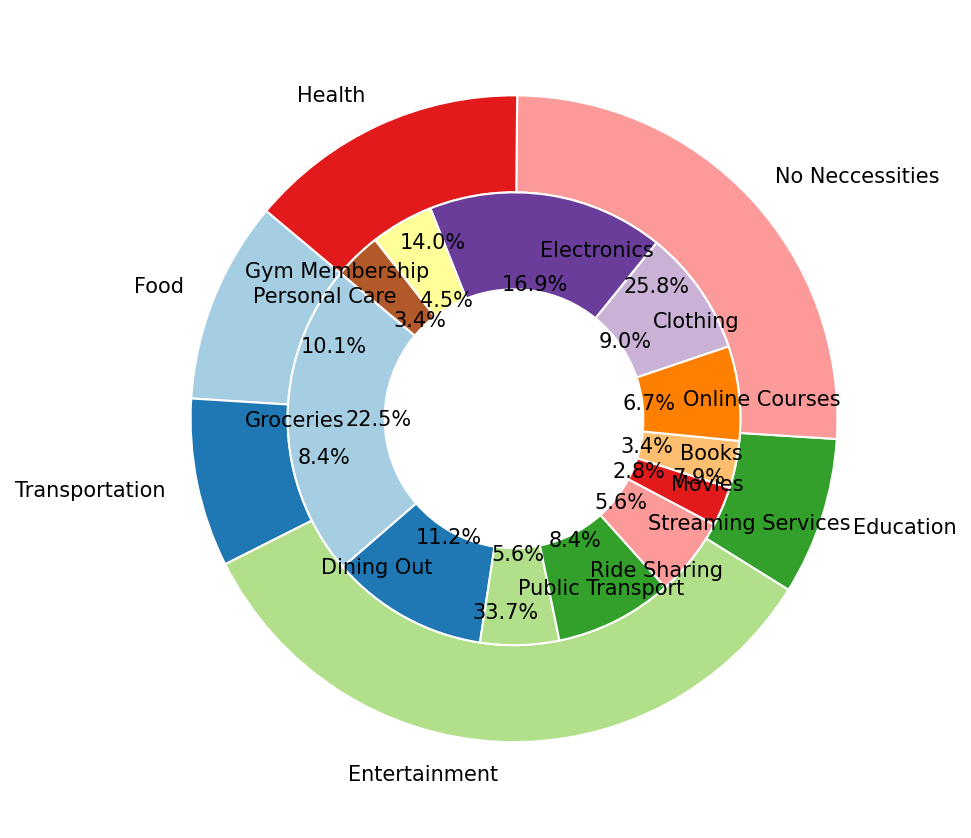What category has the highest monthly expense? By looking at the outer pie chart, we can identify the category with the largest section. Food, with its subcategories Groceries and Dining Out, has the highest monthly expense.
Answer: Food What is the total monthly expense for the Entertainment category? Add the monthly expenses for the subcategories Streaming Services ($50) and Movies ($25). This gives $50 + $25 = $75.
Answer: $75 Which subcategory within the Transportation category has a higher monthly expense? By comparing the sections within Transportation, Ride Sharing has a higher expense ($75) compared to Public Transport ($50).
Answer: Ride Sharing What is the color of the section representing the Education category's total monthly expenditure? The outer pie chart segment marked as Education, which includes Books and Online Courses, is colored light blue-ish in the chart.
Answer: Light Blue How many categories have only one subcategory and what are they? From the pie chart, identify the categories with single sections in the inner pie chart. These are Health and Non-Necessities, as Gym Membership and Electronics are their sole subcategories.
Answer: Two, Health and Non-Necessities Which subcategory has the lowest frequency of purchases? By looking at the inner pie chart, the subcategory with the smallest section in frequency (1 purchase) and monthly expense is Electronics within Non-Necessities.
Answer: Electronics Which category has the smallest proportion of the total monthly expense, and what is its monthly expense? The smallest outer pie chart segment of a category represents Health, made up of Gym Membership ($40) and Personal Care ($30), summing to $70.
Answer: Health, $70 How does the percentage of monthly expense on Groceries compare to Dining Out? Visually, Groceries takes a larger slice in the inner pie chart than Dining Out. Groceries is represented by around 20.8%, whereas Dining Out is 10.4%.
Answer: Groceries is larger What is the combined monthly expense for categories where each subcategory has equal frequency of purchases? Identify these from the inner pie chart. Only Education (Books and Online Courses both with frequency 1) fits. Summing their expenses, $30 + $60 = $90.
Answer: $90 